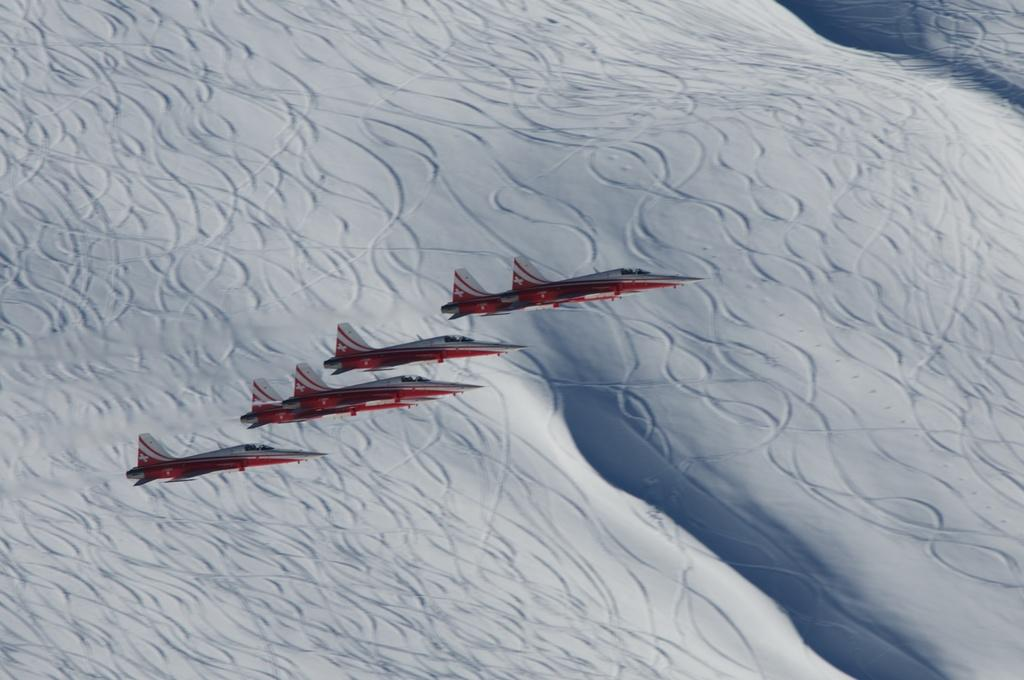What is happening in the image? There are aircrafts flying in the image. What colors are the aircrafts? The aircrafts are in red and white colors. What can be seen at the bottom of the image? There appears to be snow at the bottom of the image. What type of jam is being spread on the stocking in the image? There is no jam or stocking present in the image; it features aircrafts flying and snow at the bottom. How many bubbles can be seen floating around the aircrafts in the image? There are no bubbles present in the image; it only features aircrafts and snow. 